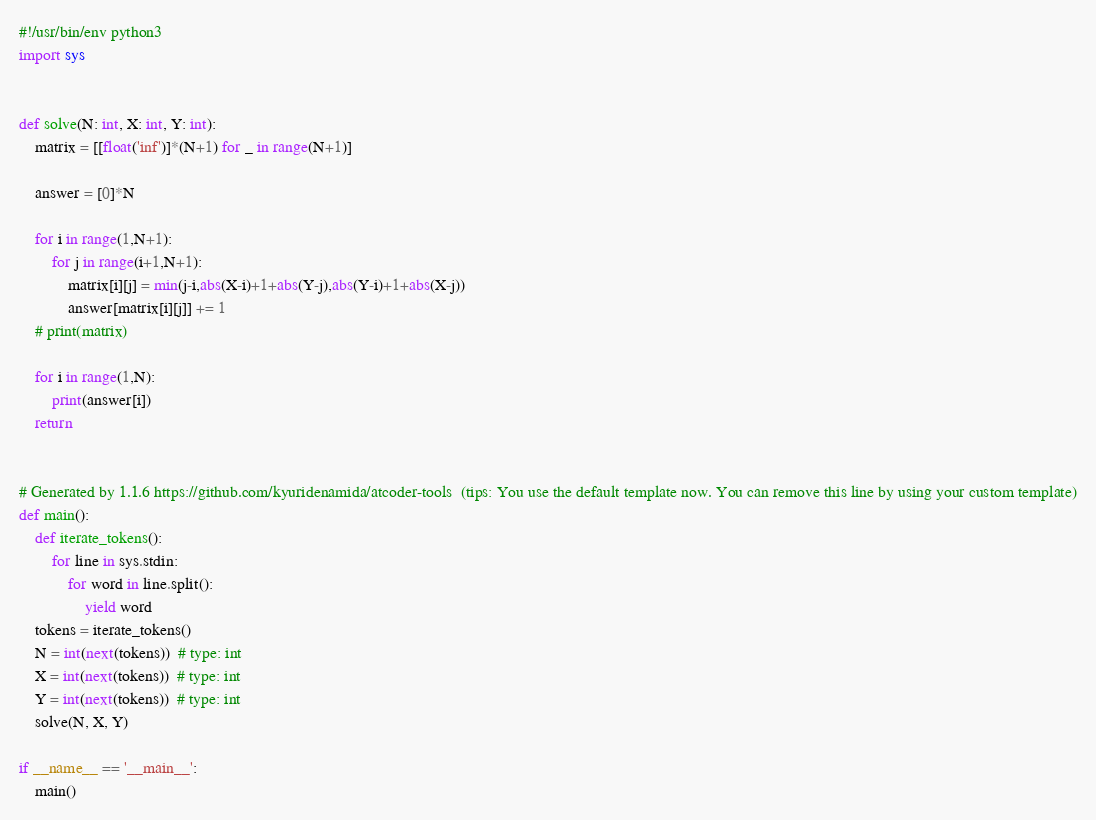<code> <loc_0><loc_0><loc_500><loc_500><_Python_>#!/usr/bin/env python3
import sys


def solve(N: int, X: int, Y: int):
    matrix = [[float('inf')]*(N+1) for _ in range(N+1)]

    answer = [0]*N

    for i in range(1,N+1):
        for j in range(i+1,N+1):
            matrix[i][j] = min(j-i,abs(X-i)+1+abs(Y-j),abs(Y-i)+1+abs(X-j))
            answer[matrix[i][j]] += 1
    # print(matrix)

    for i in range(1,N):
        print(answer[i])
    return


# Generated by 1.1.6 https://github.com/kyuridenamida/atcoder-tools  (tips: You use the default template now. You can remove this line by using your custom template)
def main():
    def iterate_tokens():
        for line in sys.stdin:
            for word in line.split():
                yield word
    tokens = iterate_tokens()
    N = int(next(tokens))  # type: int
    X = int(next(tokens))  # type: int
    Y = int(next(tokens))  # type: int
    solve(N, X, Y)

if __name__ == '__main__':
    main()
</code> 